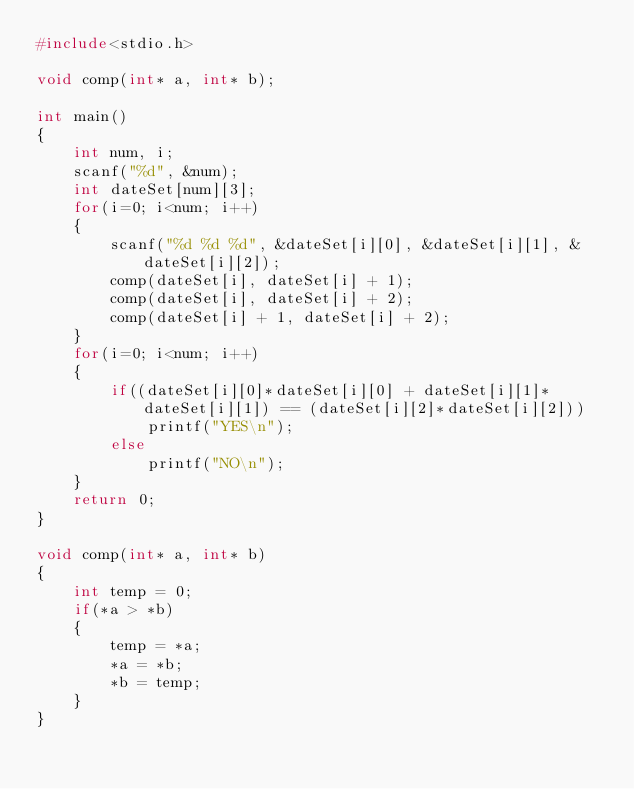<code> <loc_0><loc_0><loc_500><loc_500><_C_>#include<stdio.h>

void comp(int* a, int* b);

int main()
{
    int num, i;
    scanf("%d", &num);
    int dateSet[num][3];
    for(i=0; i<num; i++)
    {
        scanf("%d %d %d", &dateSet[i][0], &dateSet[i][1], &dateSet[i][2]);
        comp(dateSet[i], dateSet[i] + 1);
        comp(dateSet[i], dateSet[i] + 2);
        comp(dateSet[i] + 1, dateSet[i] + 2);
    }
    for(i=0; i<num; i++)
    {
        if((dateSet[i][0]*dateSet[i][0] + dateSet[i][1]*dateSet[i][1]) == (dateSet[i][2]*dateSet[i][2]))
            printf("YES\n");
        else
            printf("NO\n");
    }
    return 0;
}

void comp(int* a, int* b)
{
    int temp = 0;
    if(*a > *b)
    {
        temp = *a;
        *a = *b;
        *b = temp;
    }
}
</code> 